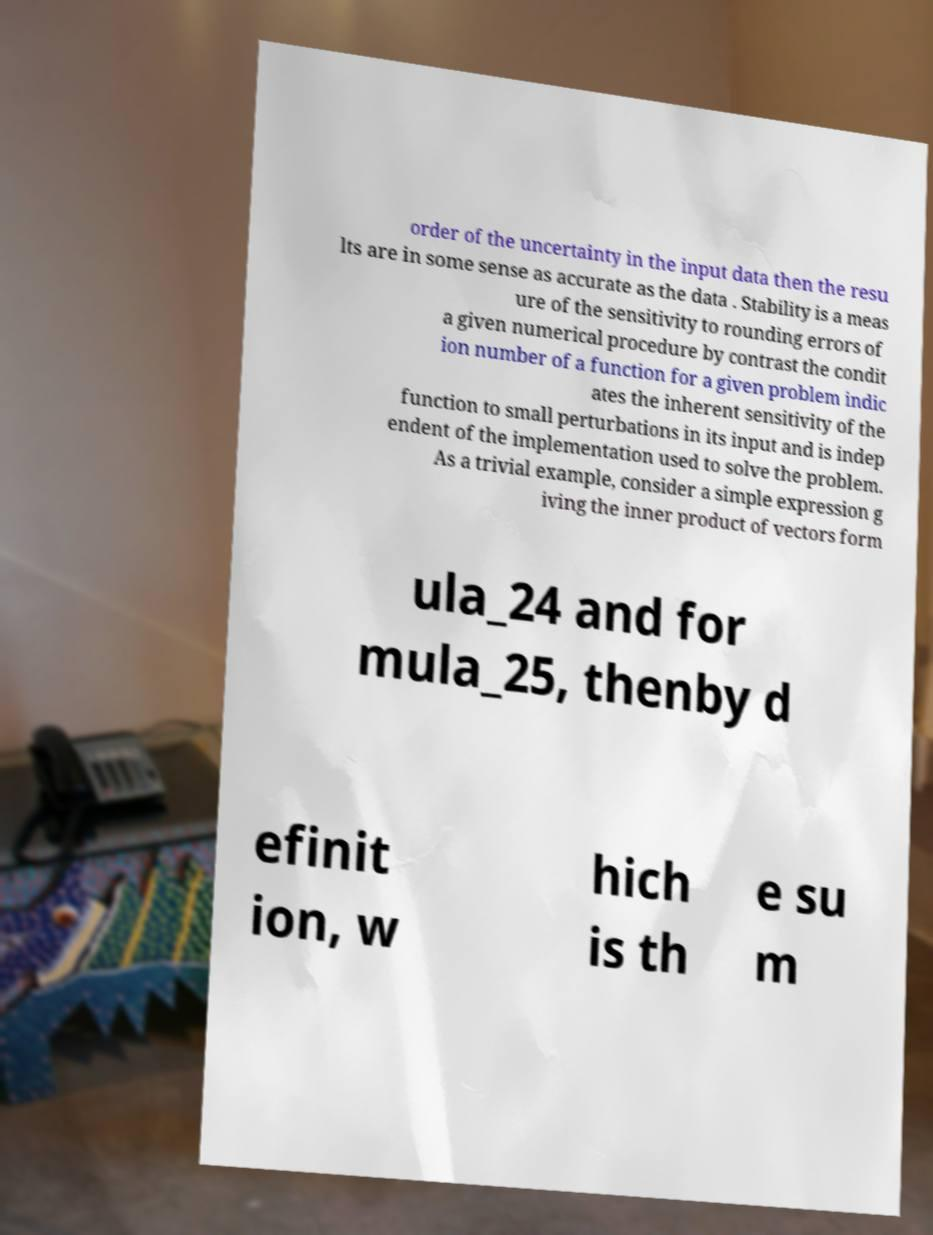For documentation purposes, I need the text within this image transcribed. Could you provide that? order of the uncertainty in the input data then the resu lts are in some sense as accurate as the data . Stability is a meas ure of the sensitivity to rounding errors of a given numerical procedure by contrast the condit ion number of a function for a given problem indic ates the inherent sensitivity of the function to small perturbations in its input and is indep endent of the implementation used to solve the problem. As a trivial example, consider a simple expression g iving the inner product of vectors form ula_24 and for mula_25, thenby d efinit ion, w hich is th e su m 